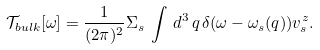Convert formula to latex. <formula><loc_0><loc_0><loc_500><loc_500>\mathcal { T } _ { b u l k } [ \omega ] = \frac { 1 } { ( 2 \pi ) ^ { 2 } } \Sigma _ { s } \, \int \, d ^ { 3 } \, { q } \, \delta ( \omega - \omega _ { s } ( { q } ) ) v _ { s } ^ { z } .</formula> 